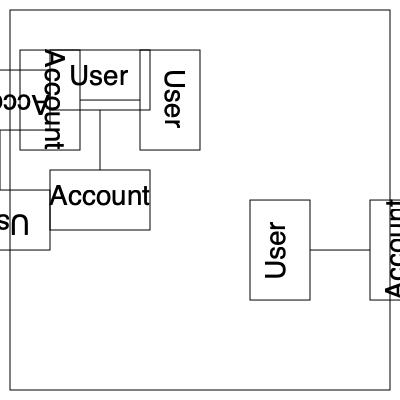Which of the rotated diagrams (1, 2, or 3) represents a 180-degree rotation of the original Java class diagram in the top-left corner? To solve this problem, we need to analyze each rotated diagram and compare it to the original diagram:

1. Original diagram (top-left):
   - User class on top
   - Account class on bottom
   - Connection line pointing downwards

2. Rotated diagram 1 (top-right):
   - Rotated 90 degrees clockwise
   - User class on right
   - Account class on left
   - Connection line pointing left

3. Rotated diagram 2 (bottom-left):
   - Rotated 180 degrees
   - User class on bottom
   - Account class on top
   - Connection line pointing upwards

4. Rotated diagram 3 (bottom-right):
   - Rotated 90 degrees counterclockwise
   - User class on left
   - Account class on right
   - Connection line pointing right

A 180-degree rotation would result in:
   - User and Account classes swapping positions (top to bottom)
   - Connection line pointing in the opposite direction

Comparing these characteristics, we can see that Rotated diagram 2 (bottom-left) matches the description of a 180-degree rotation of the original diagram.
Answer: 2 